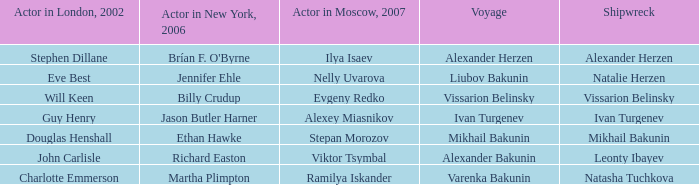In moscow, which actor played the role that john carlisle portrayed in london in 2002? Viktor Tsymbal. 